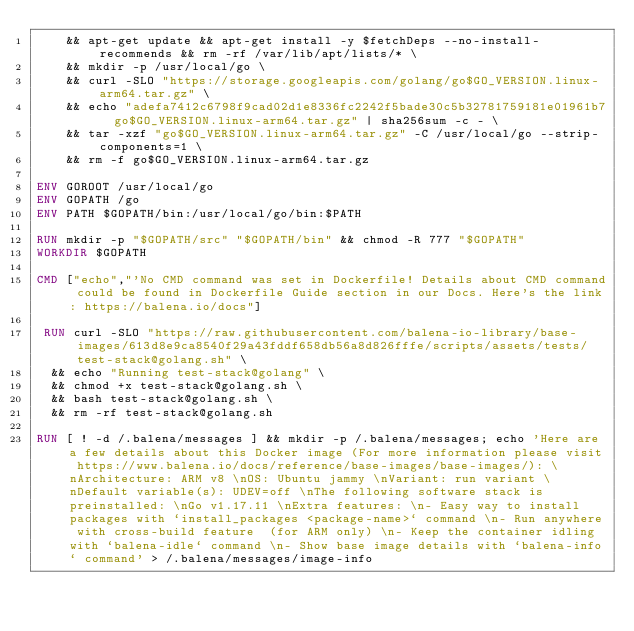Convert code to text. <code><loc_0><loc_0><loc_500><loc_500><_Dockerfile_>	&& apt-get update && apt-get install -y $fetchDeps --no-install-recommends && rm -rf /var/lib/apt/lists/* \
	&& mkdir -p /usr/local/go \
	&& curl -SLO "https://storage.googleapis.com/golang/go$GO_VERSION.linux-arm64.tar.gz" \
	&& echo "adefa7412c6798f9cad02d1e8336fc2242f5bade30c5b32781759181e01961b7  go$GO_VERSION.linux-arm64.tar.gz" | sha256sum -c - \
	&& tar -xzf "go$GO_VERSION.linux-arm64.tar.gz" -C /usr/local/go --strip-components=1 \
	&& rm -f go$GO_VERSION.linux-arm64.tar.gz

ENV GOROOT /usr/local/go
ENV GOPATH /go
ENV PATH $GOPATH/bin:/usr/local/go/bin:$PATH

RUN mkdir -p "$GOPATH/src" "$GOPATH/bin" && chmod -R 777 "$GOPATH"
WORKDIR $GOPATH

CMD ["echo","'No CMD command was set in Dockerfile! Details about CMD command could be found in Dockerfile Guide section in our Docs. Here's the link: https://balena.io/docs"]

 RUN curl -SLO "https://raw.githubusercontent.com/balena-io-library/base-images/613d8e9ca8540f29a43fddf658db56a8d826fffe/scripts/assets/tests/test-stack@golang.sh" \
  && echo "Running test-stack@golang" \
  && chmod +x test-stack@golang.sh \
  && bash test-stack@golang.sh \
  && rm -rf test-stack@golang.sh 

RUN [ ! -d /.balena/messages ] && mkdir -p /.balena/messages; echo 'Here are a few details about this Docker image (For more information please visit https://www.balena.io/docs/reference/base-images/base-images/): \nArchitecture: ARM v8 \nOS: Ubuntu jammy \nVariant: run variant \nDefault variable(s): UDEV=off \nThe following software stack is preinstalled: \nGo v1.17.11 \nExtra features: \n- Easy way to install packages with `install_packages <package-name>` command \n- Run anywhere with cross-build feature  (for ARM only) \n- Keep the container idling with `balena-idle` command \n- Show base image details with `balena-info` command' > /.balena/messages/image-info</code> 